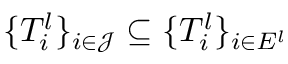<formula> <loc_0><loc_0><loc_500><loc_500>\{ T _ { i } ^ { l } \} _ { i \in \mathcal { J } } \subseteq \{ T _ { i } ^ { l } \} _ { i \in E ^ { l } }</formula> 